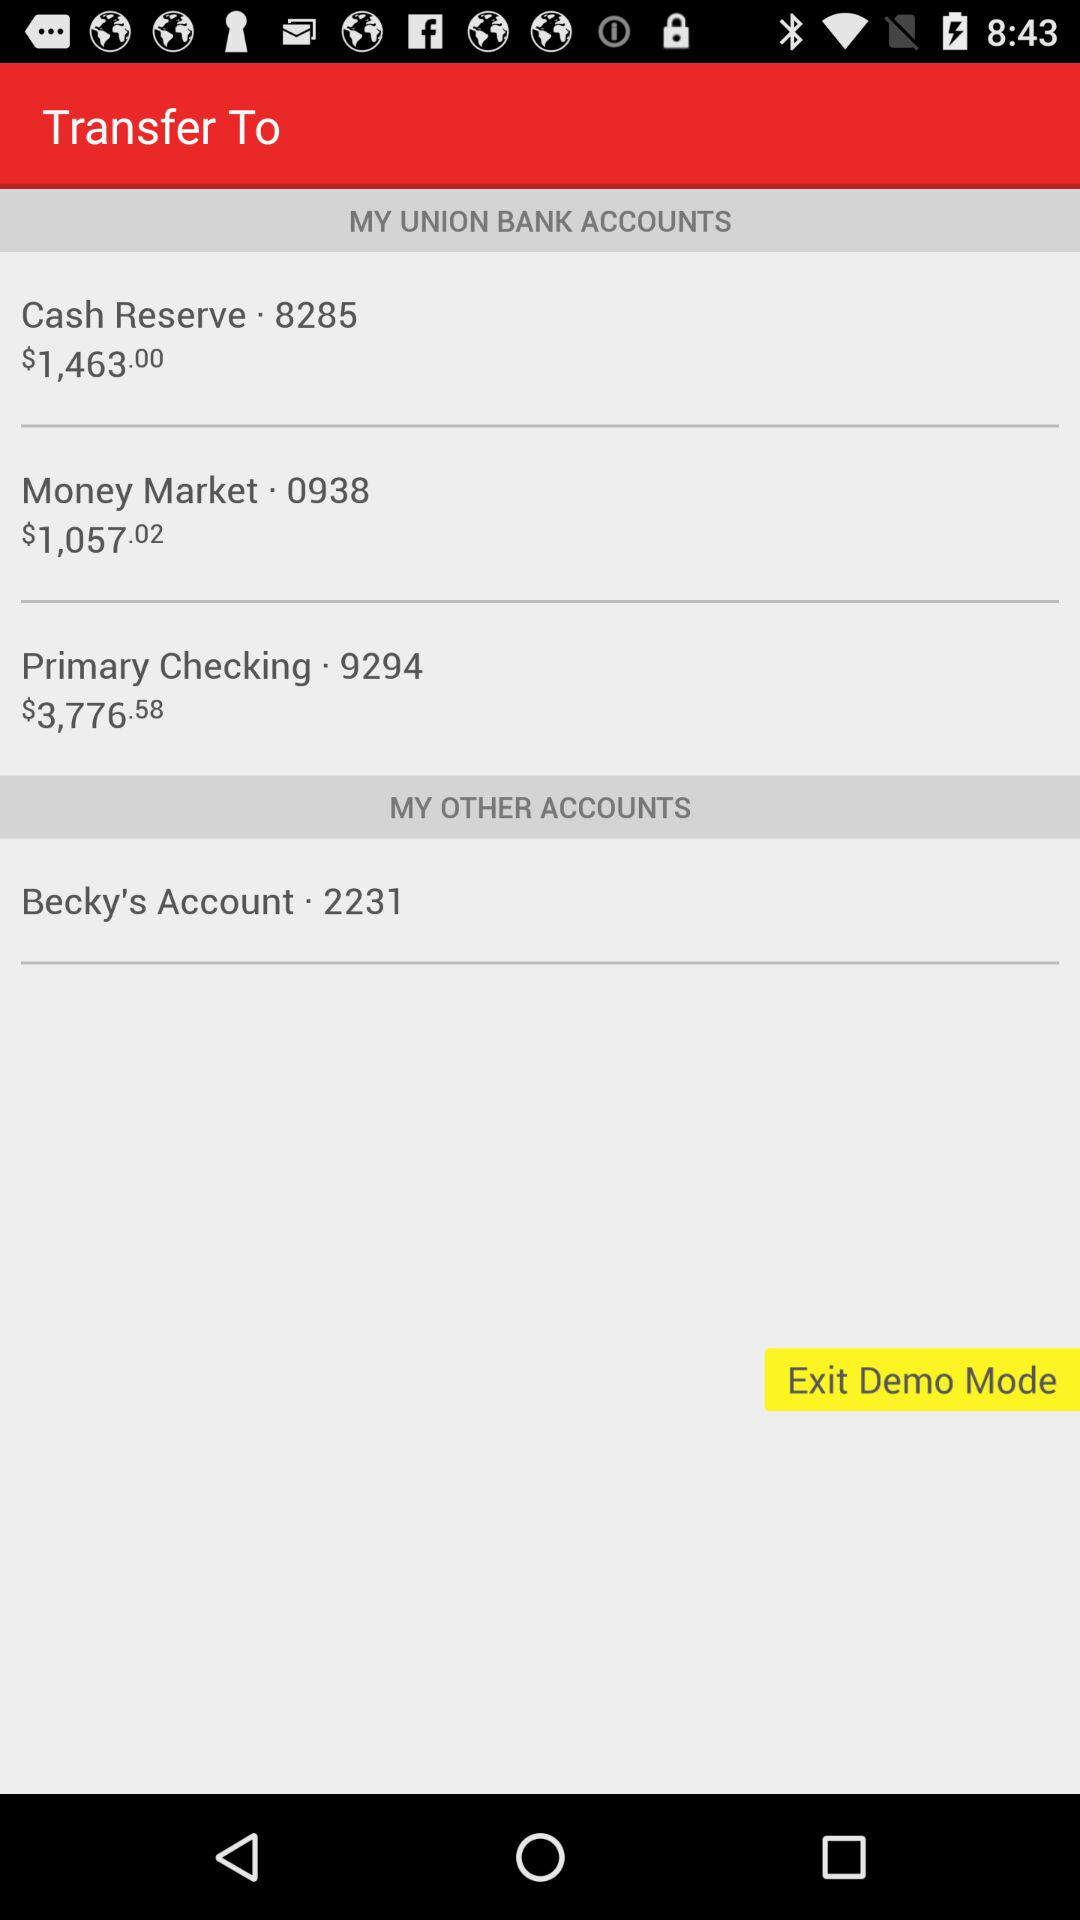What is the amount in the cash reserve? The amount in the cash reserve is $1,463.00. 